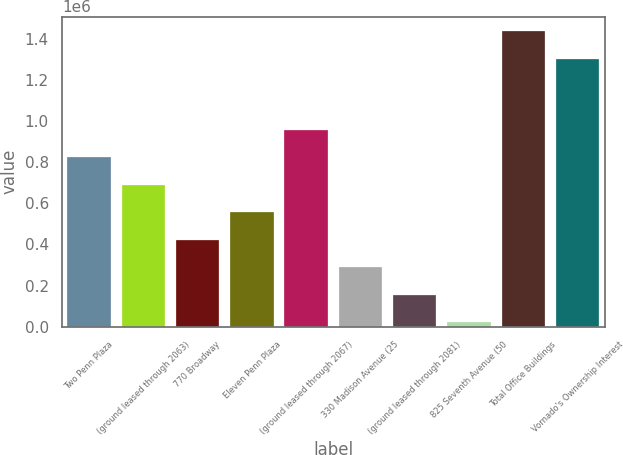<chart> <loc_0><loc_0><loc_500><loc_500><bar_chart><fcel>Two Penn Plaza<fcel>(ground leased through 2063)<fcel>770 Broadway<fcel>Eleven Penn Plaza<fcel>(ground leased through 2067)<fcel>330 Madison Avenue (25<fcel>(ground leased through 2081)<fcel>825 Seventh Avenue (50<fcel>Total Office Buildings<fcel>Vornado's Ownership Interest<nl><fcel>823722<fcel>690182<fcel>423103<fcel>556642<fcel>957261<fcel>289563<fcel>156024<fcel>22484<fcel>1.43518e+06<fcel>1.30164e+06<nl></chart> 